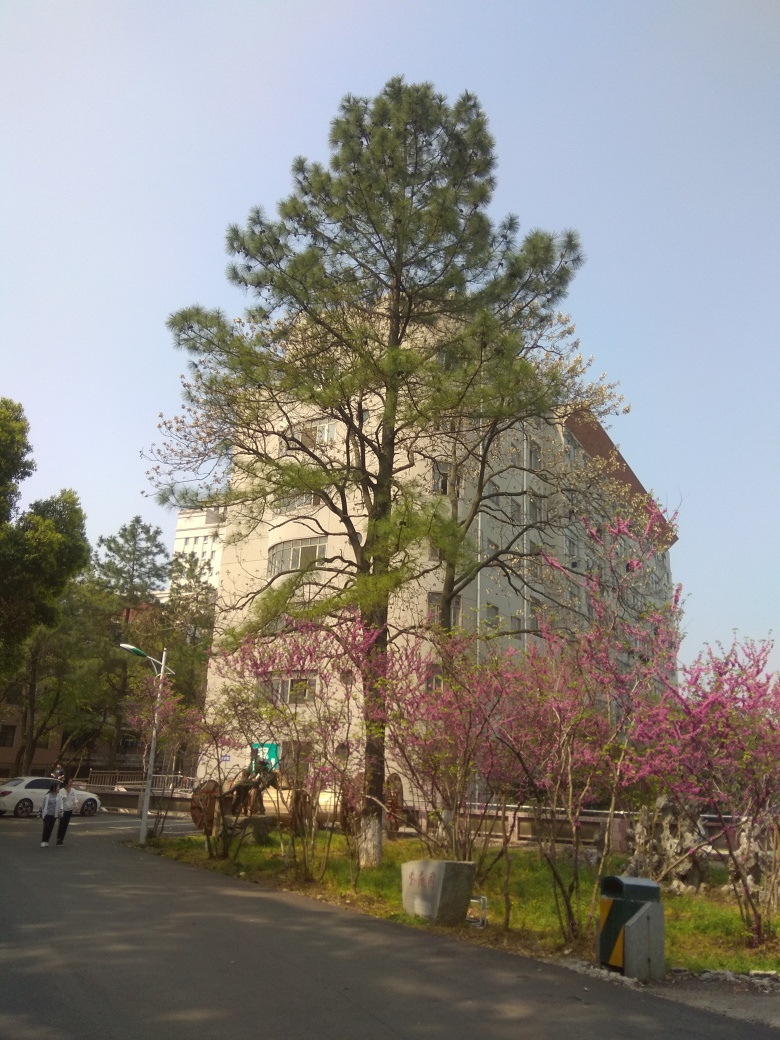Is the quality of this image considered to be moderate? The image quality is moderate based on several factors: while the main objects, such as the trees and building, are in focus and easily identifiable, the lighting is a bit harsh, possibly due to the time of day it was taken. Additionally, the image resolution is acceptable, but finer details are not as sharp as they could be with higher resolution or better camera quality. 